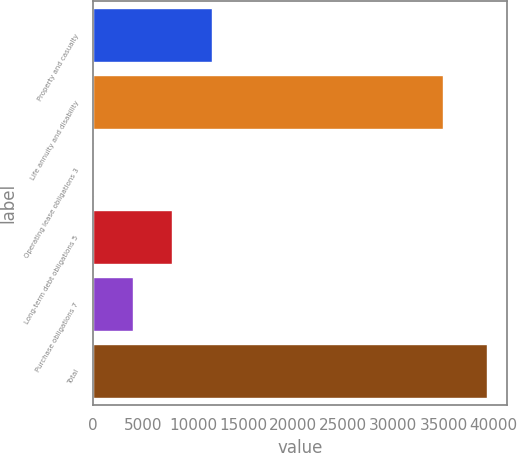Convert chart. <chart><loc_0><loc_0><loc_500><loc_500><bar_chart><fcel>Property and casualty<fcel>Life annuity and disability<fcel>Operating lease obligations 3<fcel>Long-term debt obligations 5<fcel>Purchase obligations 7<fcel>Total<nl><fcel>11846.9<fcel>34993<fcel>53<fcel>7915.6<fcel>3984.3<fcel>39366<nl></chart> 